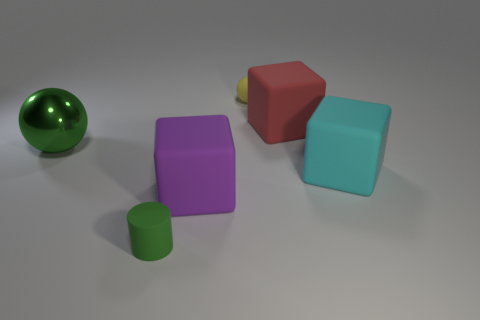Add 4 big green metal objects. How many objects exist? 10 Subtract all spheres. How many objects are left? 4 Add 6 purple rubber things. How many purple rubber things are left? 7 Add 5 yellow objects. How many yellow objects exist? 6 Subtract 0 yellow cylinders. How many objects are left? 6 Subtract all big cyan cubes. Subtract all green rubber cylinders. How many objects are left? 4 